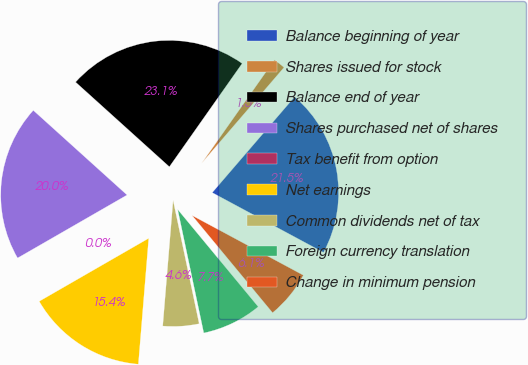<chart> <loc_0><loc_0><loc_500><loc_500><pie_chart><fcel>Balance beginning of year<fcel>Shares issued for stock<fcel>Balance end of year<fcel>Shares purchased net of shares<fcel>Tax benefit from option<fcel>Net earnings<fcel>Common dividends net of tax<fcel>Foreign currency translation<fcel>Change in minimum pension<nl><fcel>21.54%<fcel>1.54%<fcel>23.08%<fcel>20.0%<fcel>0.0%<fcel>15.38%<fcel>4.62%<fcel>7.69%<fcel>6.15%<nl></chart> 